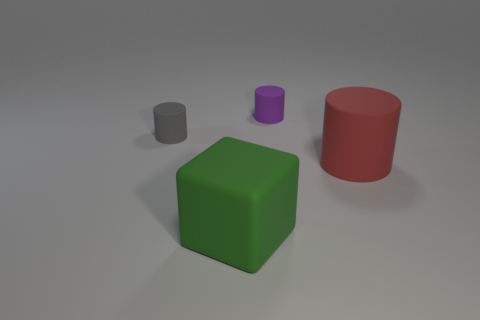Subtract all small purple cylinders. How many cylinders are left? 2 Add 1 large red metal cylinders. How many objects exist? 5 Subtract all purple cylinders. How many cylinders are left? 2 Subtract all blocks. How many objects are left? 3 Subtract 3 cylinders. How many cylinders are left? 0 Subtract all cyan blocks. Subtract all gray balls. How many blocks are left? 1 Subtract all large matte blocks. Subtract all green matte things. How many objects are left? 2 Add 4 purple matte cylinders. How many purple matte cylinders are left? 5 Add 4 tiny rubber cylinders. How many tiny rubber cylinders exist? 6 Subtract 0 blue spheres. How many objects are left? 4 